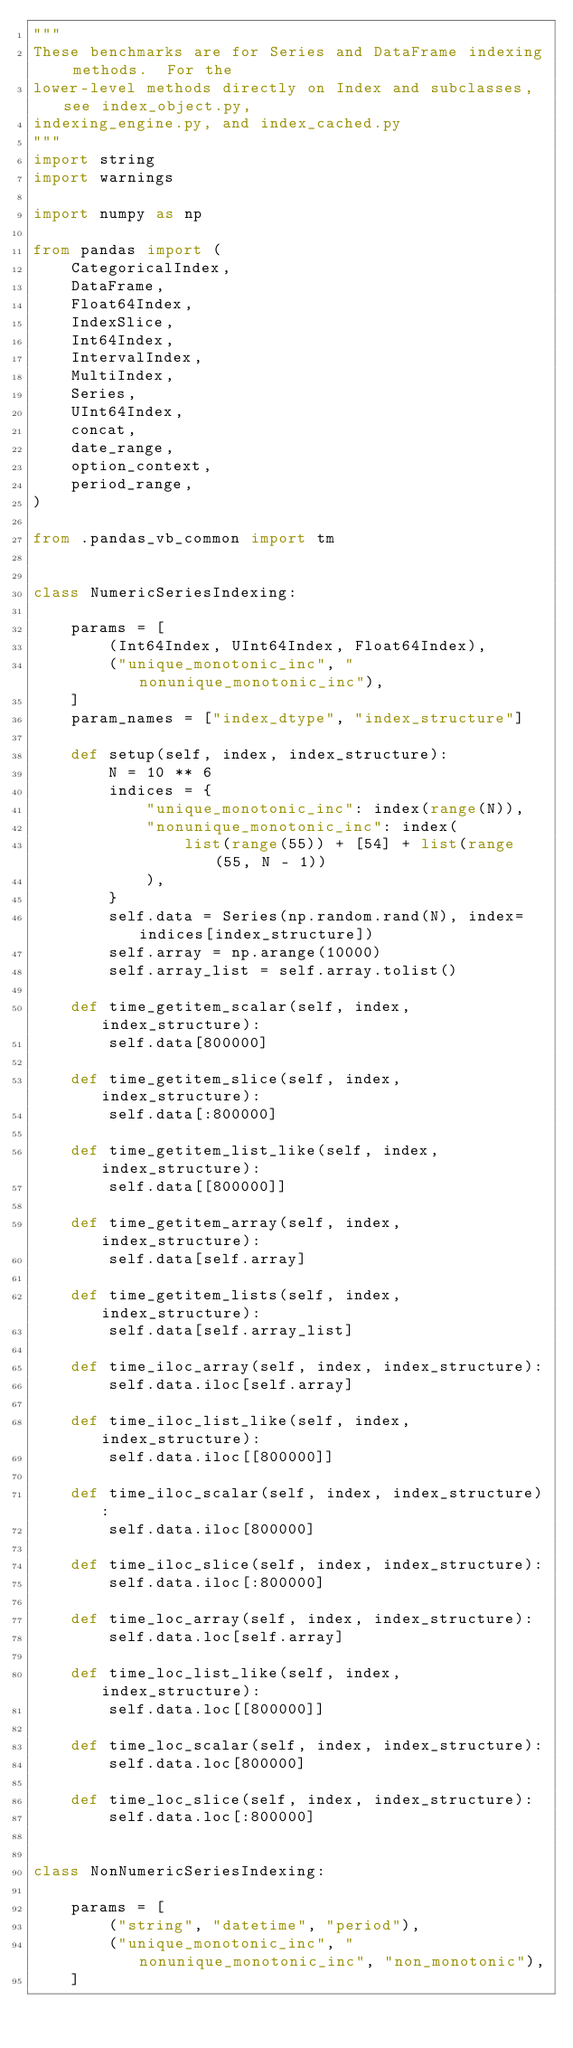<code> <loc_0><loc_0><loc_500><loc_500><_Python_>"""
These benchmarks are for Series and DataFrame indexing methods.  For the
lower-level methods directly on Index and subclasses, see index_object.py,
indexing_engine.py, and index_cached.py
"""
import string
import warnings

import numpy as np

from pandas import (
    CategoricalIndex,
    DataFrame,
    Float64Index,
    IndexSlice,
    Int64Index,
    IntervalIndex,
    MultiIndex,
    Series,
    UInt64Index,
    concat,
    date_range,
    option_context,
    period_range,
)

from .pandas_vb_common import tm


class NumericSeriesIndexing:

    params = [
        (Int64Index, UInt64Index, Float64Index),
        ("unique_monotonic_inc", "nonunique_monotonic_inc"),
    ]
    param_names = ["index_dtype", "index_structure"]

    def setup(self, index, index_structure):
        N = 10 ** 6
        indices = {
            "unique_monotonic_inc": index(range(N)),
            "nonunique_monotonic_inc": index(
                list(range(55)) + [54] + list(range(55, N - 1))
            ),
        }
        self.data = Series(np.random.rand(N), index=indices[index_structure])
        self.array = np.arange(10000)
        self.array_list = self.array.tolist()

    def time_getitem_scalar(self, index, index_structure):
        self.data[800000]

    def time_getitem_slice(self, index, index_structure):
        self.data[:800000]

    def time_getitem_list_like(self, index, index_structure):
        self.data[[800000]]

    def time_getitem_array(self, index, index_structure):
        self.data[self.array]

    def time_getitem_lists(self, index, index_structure):
        self.data[self.array_list]

    def time_iloc_array(self, index, index_structure):
        self.data.iloc[self.array]

    def time_iloc_list_like(self, index, index_structure):
        self.data.iloc[[800000]]

    def time_iloc_scalar(self, index, index_structure):
        self.data.iloc[800000]

    def time_iloc_slice(self, index, index_structure):
        self.data.iloc[:800000]

    def time_loc_array(self, index, index_structure):
        self.data.loc[self.array]

    def time_loc_list_like(self, index, index_structure):
        self.data.loc[[800000]]

    def time_loc_scalar(self, index, index_structure):
        self.data.loc[800000]

    def time_loc_slice(self, index, index_structure):
        self.data.loc[:800000]


class NonNumericSeriesIndexing:

    params = [
        ("string", "datetime", "period"),
        ("unique_monotonic_inc", "nonunique_monotonic_inc", "non_monotonic"),
    ]</code> 